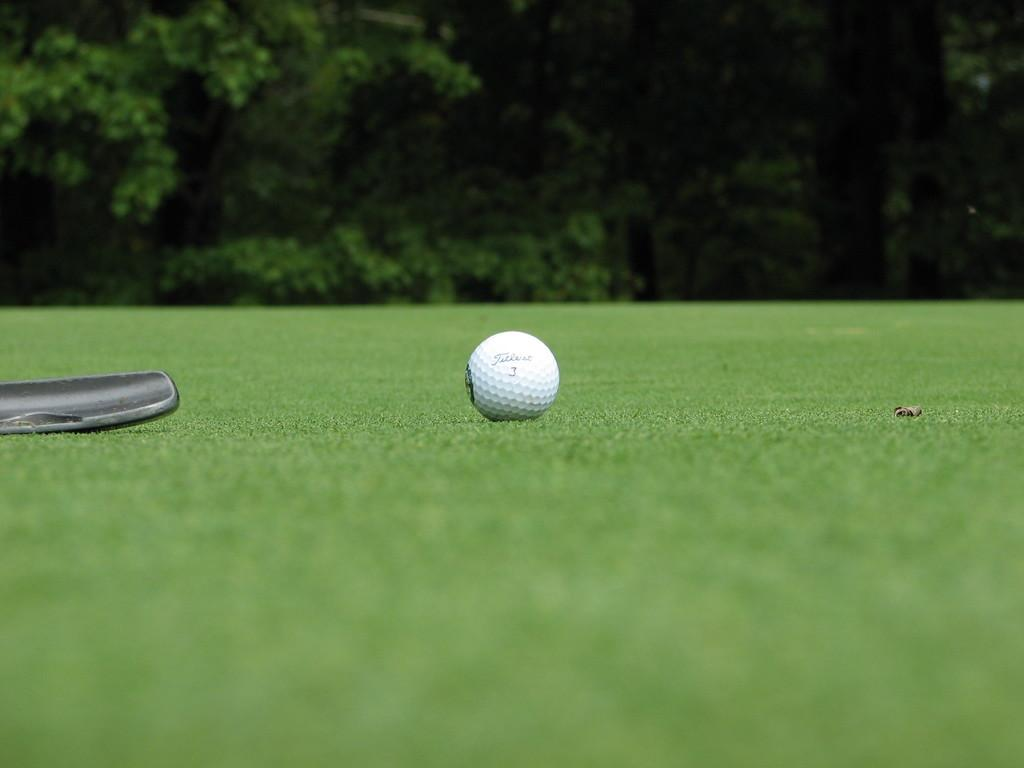What object is present on the grass floor in the image? There is a ball on the grass floor in the image. What type of surface is the ball resting on? The ball is on the grass floor. What can be seen in the background behind the ball? There are trees and plants behind the ball. What color bead is being held by the hands in the image? There are no beads or hands present in the image; it only features a ball on the grass floor and trees and plants in the background. 